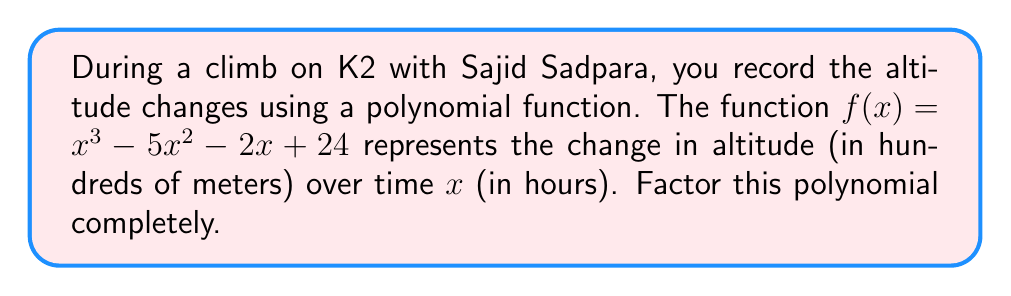What is the answer to this math problem? Let's approach this step-by-step:

1) First, we should check if there are any rational roots using the rational root theorem. The possible rational roots are the factors of the constant term: $\pm 1, \pm 2, \pm 3, \pm 4, \pm 6, \pm 8, \pm 12, \pm 24$

2) Testing these values, we find that $f(4) = 0$. So $(x-4)$ is a factor.

3) We can use polynomial long division to divide $f(x)$ by $(x-4)$:

   $x^3 - 5x^2 - 2x + 24 = (x-4)(x^2 + x - 6)$

4) Now we need to factor the quadratic term $x^2 + x - 6$

5) We can factor this using the ac-method:
   - $ac = -6$
   - We need two numbers that multiply to give -6 and add to give 1
   - These numbers are 3 and -2

6) So we can rewrite $x^2 + x - 6$ as $x^2 + 3x - 2x - 6$

7) Grouping: $(x^2 + 3x) + (-2x - 6)$
             $x(x + 3) - 2(x + 3)$
             $(x - 2)(x + 3)$

8) Therefore, the complete factorization is:

   $f(x) = (x-4)(x-2)(x+3)$

This factorization represents the different stages of altitude change during your climb with Sajid, reflecting the challenging terrain of K2.
Answer: $f(x) = (x-4)(x-2)(x+3)$ 